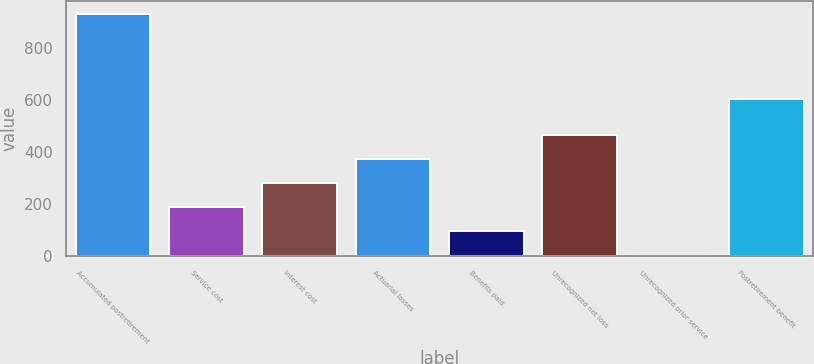<chart> <loc_0><loc_0><loc_500><loc_500><bar_chart><fcel>Accumulated postretirement<fcel>Service cost<fcel>Interest cost<fcel>Actuarial losses<fcel>Benefits paid<fcel>Unrecognized net loss<fcel>Unrecognized prior service<fcel>Postretirement benefit<nl><fcel>933<fcel>188.2<fcel>281.3<fcel>374.4<fcel>95.1<fcel>467.5<fcel>2<fcel>605<nl></chart> 